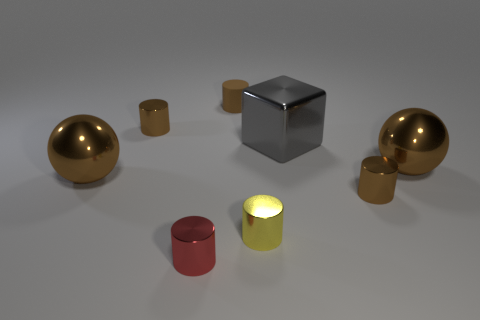What is the size of the metal cylinder that is both in front of the large gray metal cube and behind the yellow metallic cylinder? The small metal cylinder situated between the large gray cube and the yellow cylinder appears to be quite diminutive, especially when compared to the surrounding objects. Its size suggests a height that is approximately one-third of the cube's edge length and a diameter slightly less than its height. 